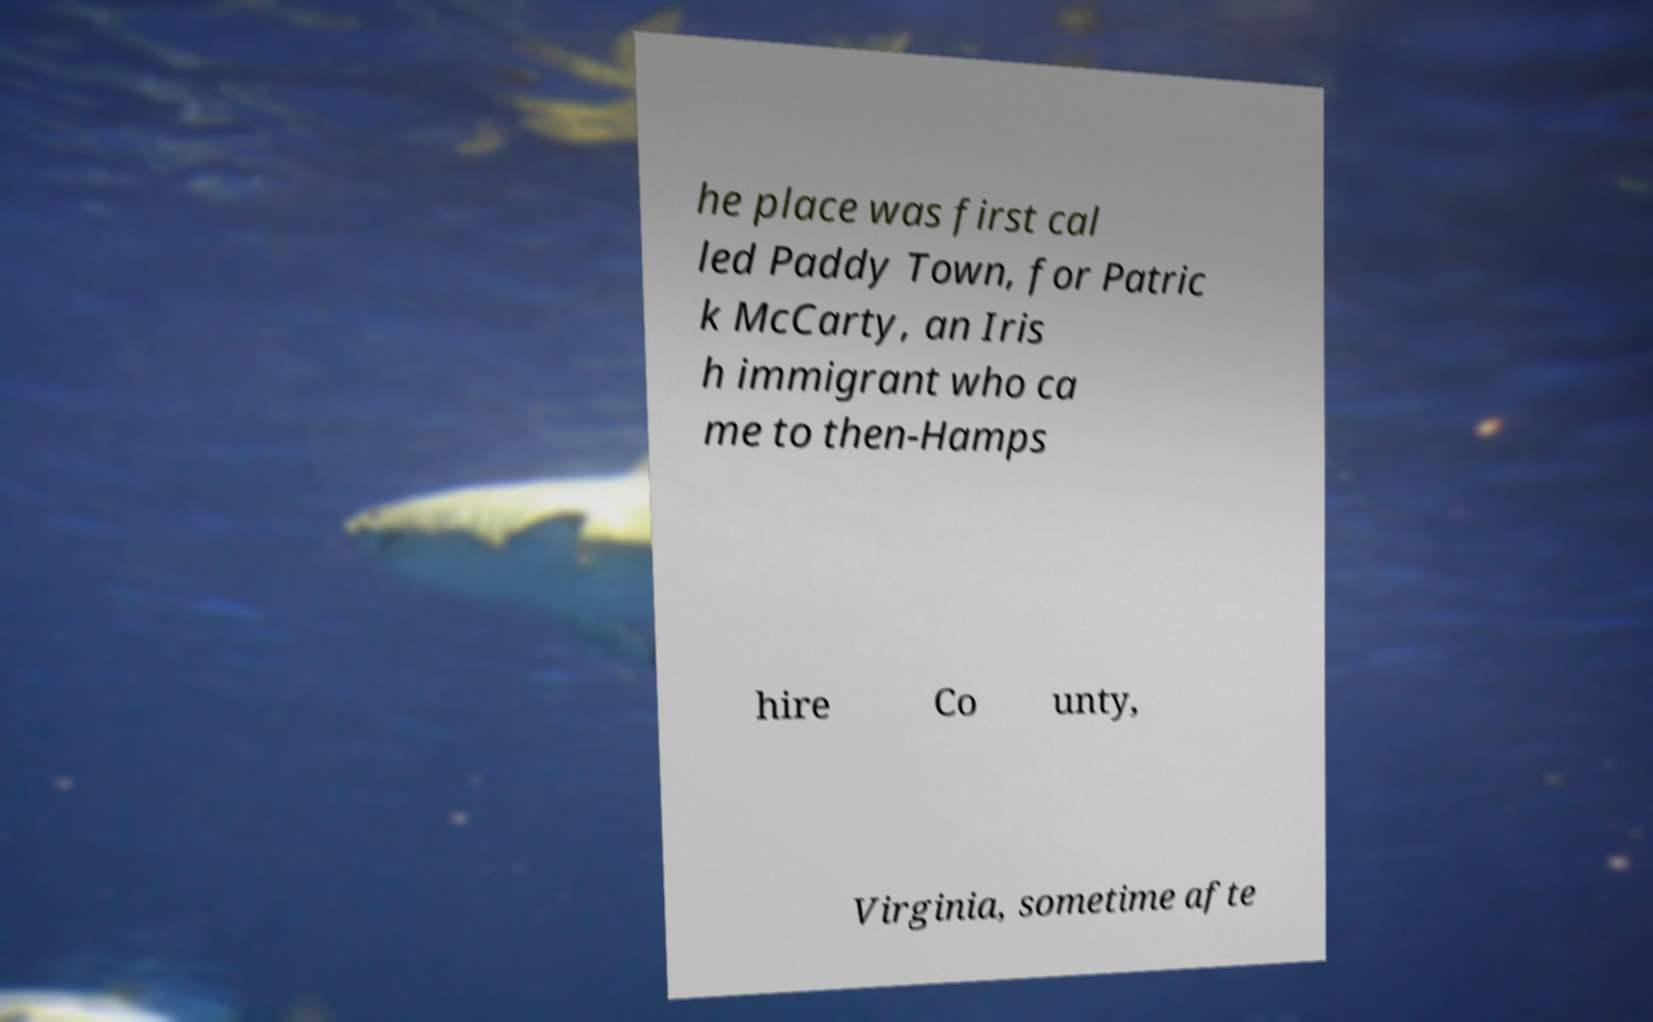Can you accurately transcribe the text from the provided image for me? he place was first cal led Paddy Town, for Patric k McCarty, an Iris h immigrant who ca me to then-Hamps hire Co unty, Virginia, sometime afte 